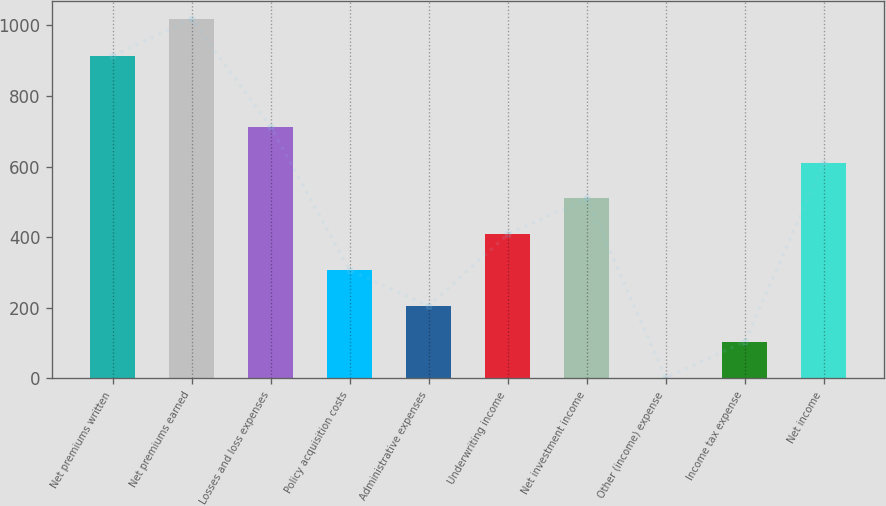Convert chart to OTSL. <chart><loc_0><loc_0><loc_500><loc_500><bar_chart><fcel>Net premiums written<fcel>Net premiums earned<fcel>Losses and loss expenses<fcel>Policy acquisition costs<fcel>Administrative expenses<fcel>Underwriting income<fcel>Net investment income<fcel>Other (income) expense<fcel>Income tax expense<fcel>Net income<nl><fcel>914<fcel>1017<fcel>712.5<fcel>306.5<fcel>205<fcel>408<fcel>509.5<fcel>2<fcel>103.5<fcel>611<nl></chart> 